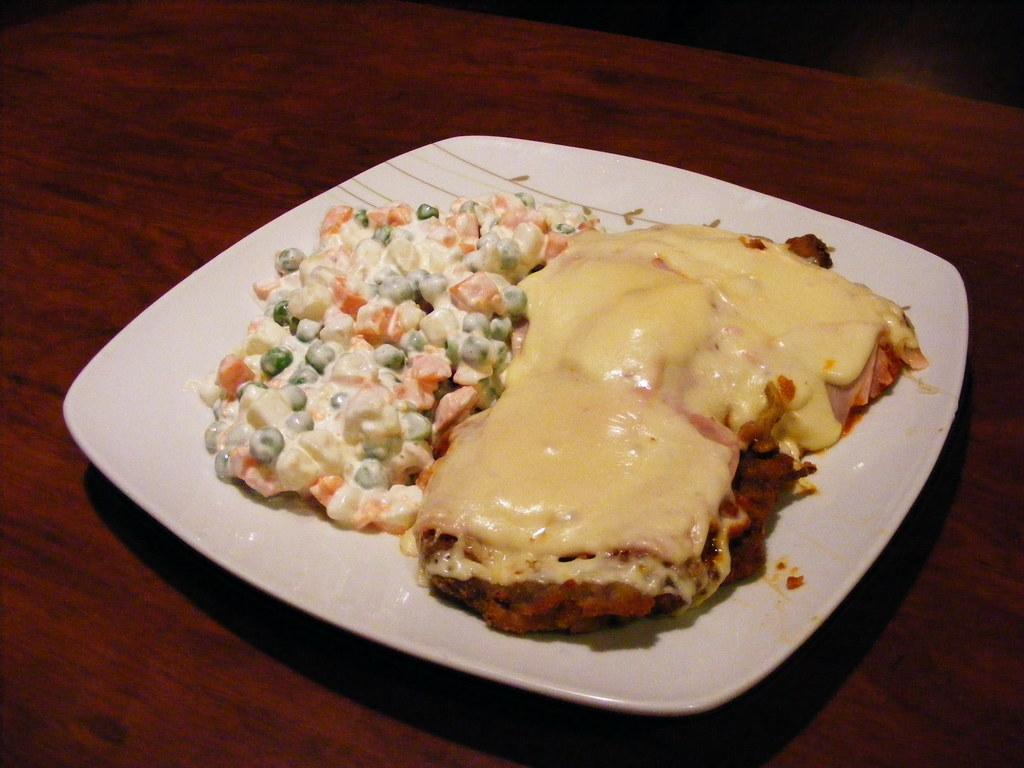What is on the plate that is visible in the image? There is a plate containing food in the image. Where is the plate located in the image? The plate is placed on a table. What type of fear can be seen on the faces of the people in the image? There are no people present in the image, so it is not possible to determine if they are experiencing any fear. 